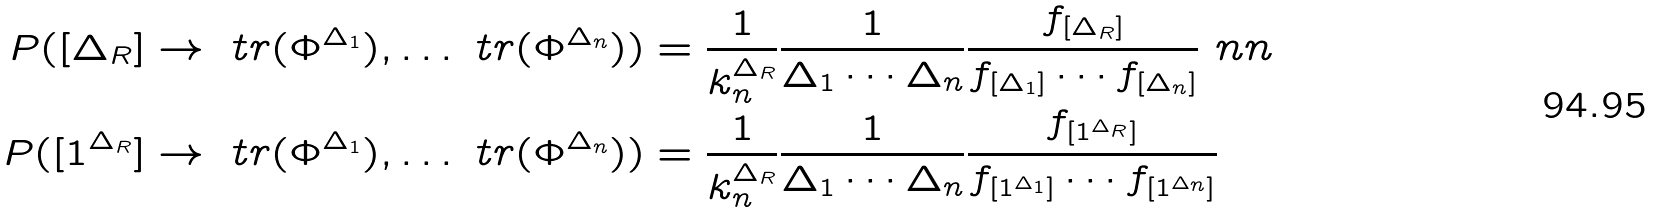<formula> <loc_0><loc_0><loc_500><loc_500>P ( [ \Delta _ { R } ] \to \ t r ( \Phi ^ { \Delta _ { 1 } } ) , \dots \ t r ( \Phi ^ { \Delta _ { n } } ) ) & = \frac { 1 } { k _ { n } ^ { \Delta _ { R } } } \frac { 1 } { \Delta _ { 1 } \cdots \Delta _ { n } } \frac { f _ { [ \Delta _ { R } ] } } { f _ { [ \Delta _ { 1 } ] } \cdots f _ { [ \Delta _ { n } ] } } \ n n \\ P ( [ 1 ^ { \Delta _ { R } } ] \to \ t r ( \Phi ^ { \Delta _ { 1 } } ) , \dots \ t r ( \Phi ^ { \Delta _ { n } } ) ) & = \frac { 1 } { k _ { n } ^ { \Delta _ { R } } } \frac { 1 } { \Delta _ { 1 } \cdots \Delta _ { n } } \frac { f _ { [ 1 ^ { \Delta _ { R } } ] } } { f _ { [ 1 ^ { \Delta _ { 1 } } ] } \cdots f _ { [ 1 ^ { \Delta _ { n } } ] } }</formula> 